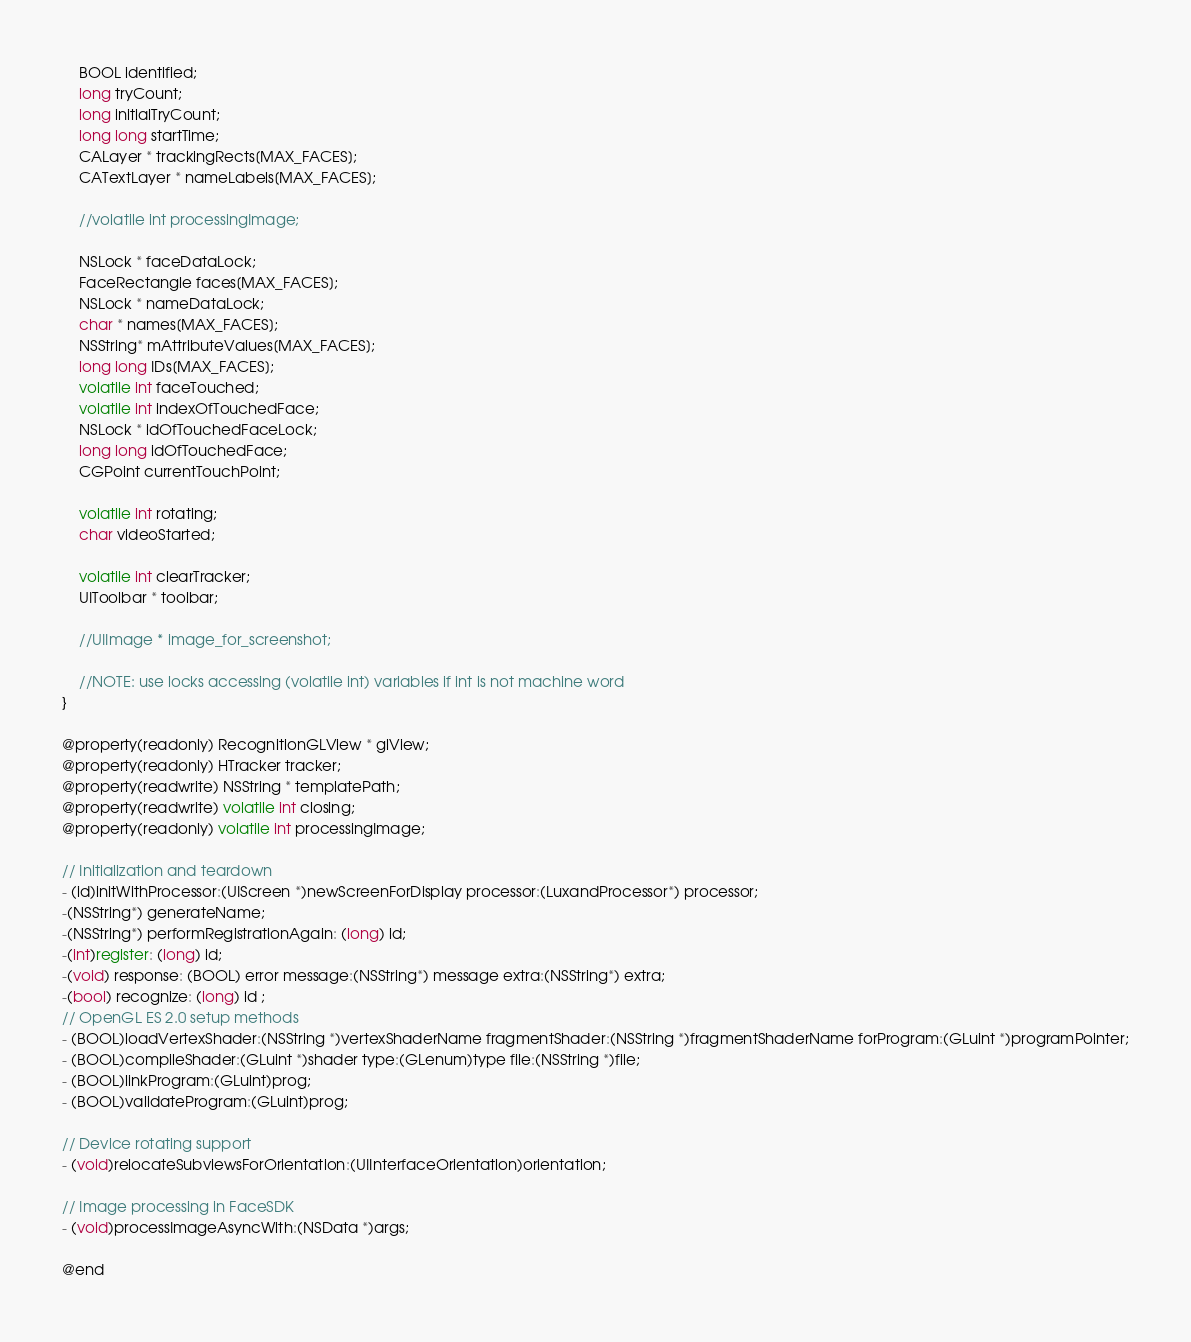Convert code to text. <code><loc_0><loc_0><loc_500><loc_500><_C_>    BOOL identified;
    long tryCount;
    long initialTryCount;
    long long startTime;
    CALayer * trackingRects[MAX_FACES];
    CATextLayer * nameLabels[MAX_FACES];
    
    //volatile int processingImage;
    
    NSLock * faceDataLock;
    FaceRectangle faces[MAX_FACES];
    NSLock * nameDataLock;
    char * names[MAX_FACES];
    NSString* mAttributeValues[MAX_FACES];
    long long IDs[MAX_FACES];
    volatile int faceTouched;
    volatile int indexOfTouchedFace;
    NSLock * idOfTouchedFaceLock;
    long long idOfTouchedFace;
    CGPoint currentTouchPoint;
	
    volatile int rotating;
    char videoStarted;
    
    volatile int clearTracker;
    UIToolbar * toolbar;
    
    //UIImage * image_for_screenshot;
    
    //NOTE: use locks accessing (volatile int) variables if int is not machine word 
}

@property(readonly) RecognitionGLView * glView;
@property(readonly) HTracker tracker;
@property(readwrite) NSString * templatePath;
@property(readwrite) volatile int closing;
@property(readonly) volatile int processingImage;

// Initialization and teardown
- (id)initWithProcessor:(UIScreen *)newScreenForDisplay processor:(LuxandProcessor*) processor;
-(NSString*) generateName;
-(NSString*) performRegistrationAgain: (long) id;
-(int)register: (long) id;
-(void) response: (BOOL) error message:(NSString*) message extra:(NSString*) extra;
-(bool) recognize: (long) id ;
// OpenGL ES 2.0 setup methods
- (BOOL)loadVertexShader:(NSString *)vertexShaderName fragmentShader:(NSString *)fragmentShaderName forProgram:(GLuint *)programPointer;
- (BOOL)compileShader:(GLuint *)shader type:(GLenum)type file:(NSString *)file;
- (BOOL)linkProgram:(GLuint)prog;
- (BOOL)validateProgram:(GLuint)prog;

// Device rotating support
- (void)relocateSubviewsForOrientation:(UIInterfaceOrientation)orientation;

// Image processing in FaceSDK
- (void)processImageAsyncWith:(NSData *)args;

@end

</code> 